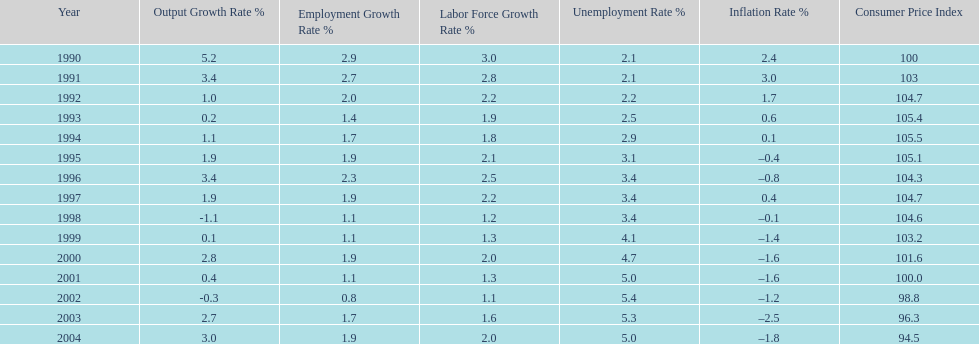What year had the highest unemployment rate? 2002. Help me parse the entirety of this table. {'header': ['Year', 'Output Growth Rate\xa0%', 'Employment Growth Rate %', 'Labor Force Growth Rate %', 'Unemployment Rate\xa0%', 'Inflation Rate\xa0%', 'Consumer Price Index'], 'rows': [['1990', '5.2', '2.9', '3.0', '2.1', '2.4', '100'], ['1991', '3.4', '2.7', '2.8', '2.1', '3.0', '103'], ['1992', '1.0', '2.0', '2.2', '2.2', '1.7', '104.7'], ['1993', '0.2', '1.4', '1.9', '2.5', '0.6', '105.4'], ['1994', '1.1', '1.7', '1.8', '2.9', '0.1', '105.5'], ['1995', '1.9', '1.9', '2.1', '3.1', '–0.4', '105.1'], ['1996', '3.4', '2.3', '2.5', '3.4', '–0.8', '104.3'], ['1997', '1.9', '1.9', '2.2', '3.4', '0.4', '104.7'], ['1998', '-1.1', '1.1', '1.2', '3.4', '–0.1', '104.6'], ['1999', '0.1', '1.1', '1.3', '4.1', '–1.4', '103.2'], ['2000', '2.8', '1.9', '2.0', '4.7', '–1.6', '101.6'], ['2001', '0.4', '1.1', '1.3', '5.0', '–1.6', '100.0'], ['2002', '-0.3', '0.8', '1.1', '5.4', '–1.2', '98.8'], ['2003', '2.7', '1.7', '1.6', '5.3', '–2.5', '96.3'], ['2004', '3.0', '1.9', '2.0', '5.0', '–1.8', '94.5']]} 